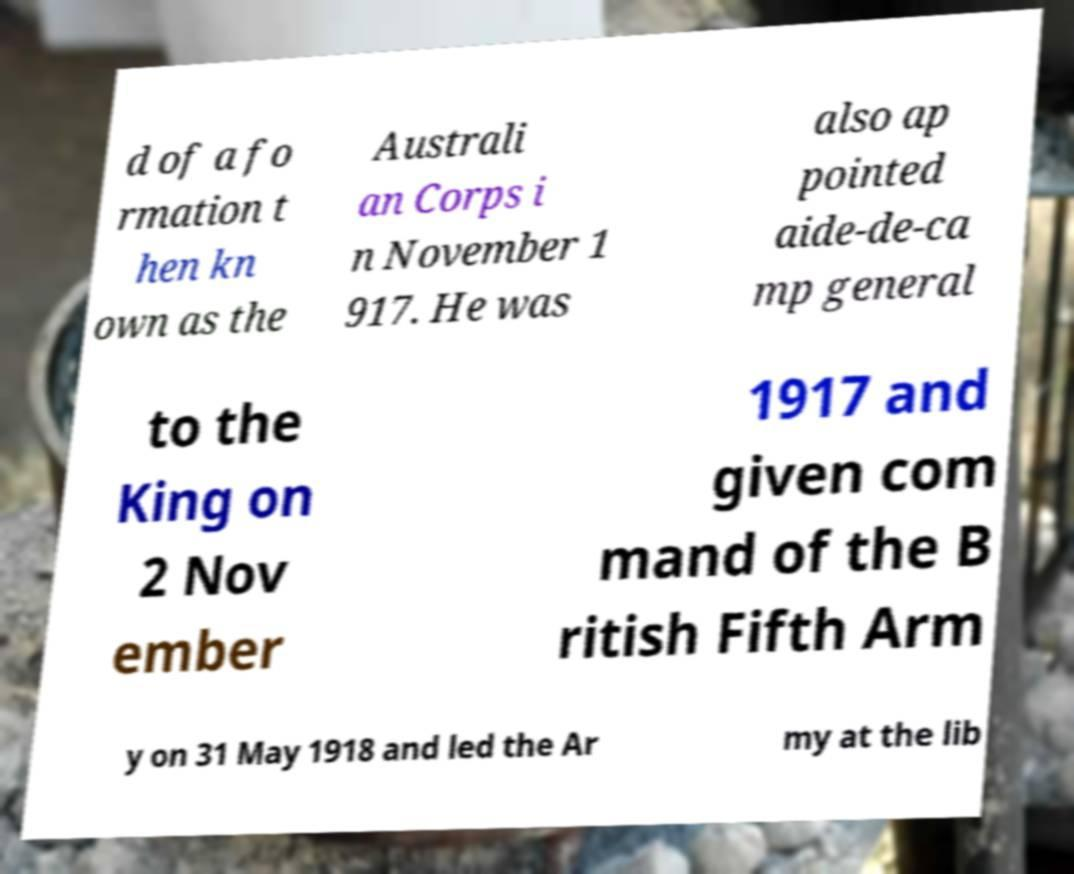Can you read and provide the text displayed in the image?This photo seems to have some interesting text. Can you extract and type it out for me? d of a fo rmation t hen kn own as the Australi an Corps i n November 1 917. He was also ap pointed aide-de-ca mp general to the King on 2 Nov ember 1917 and given com mand of the B ritish Fifth Arm y on 31 May 1918 and led the Ar my at the lib 